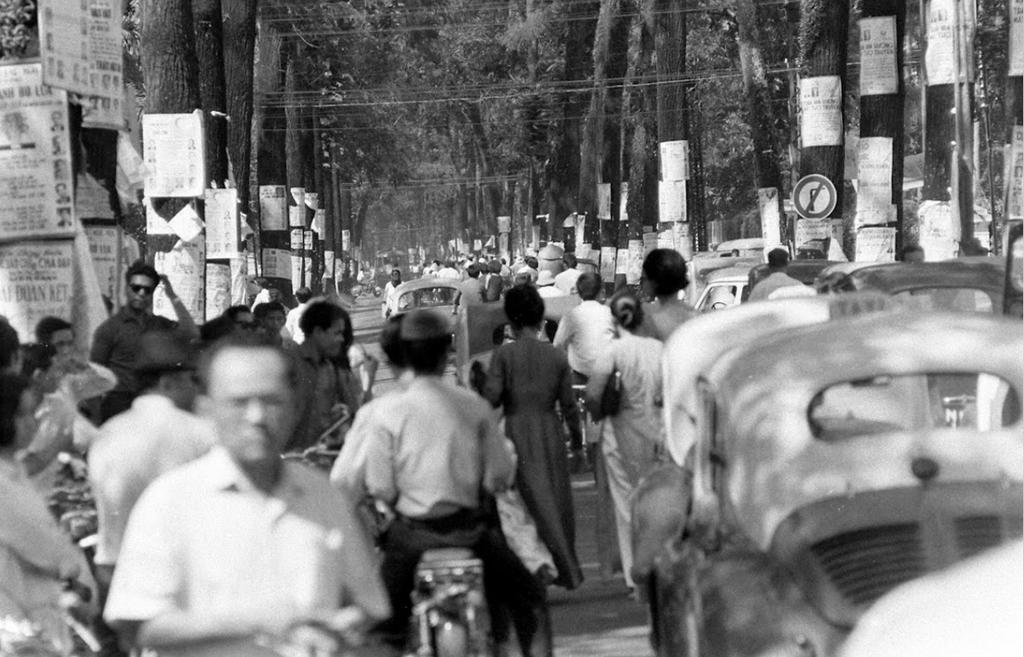Can you describe this image briefly? In this image, we can see some people walking, there are some cars on the road, we can see some trees, there are some posters on the trees. 